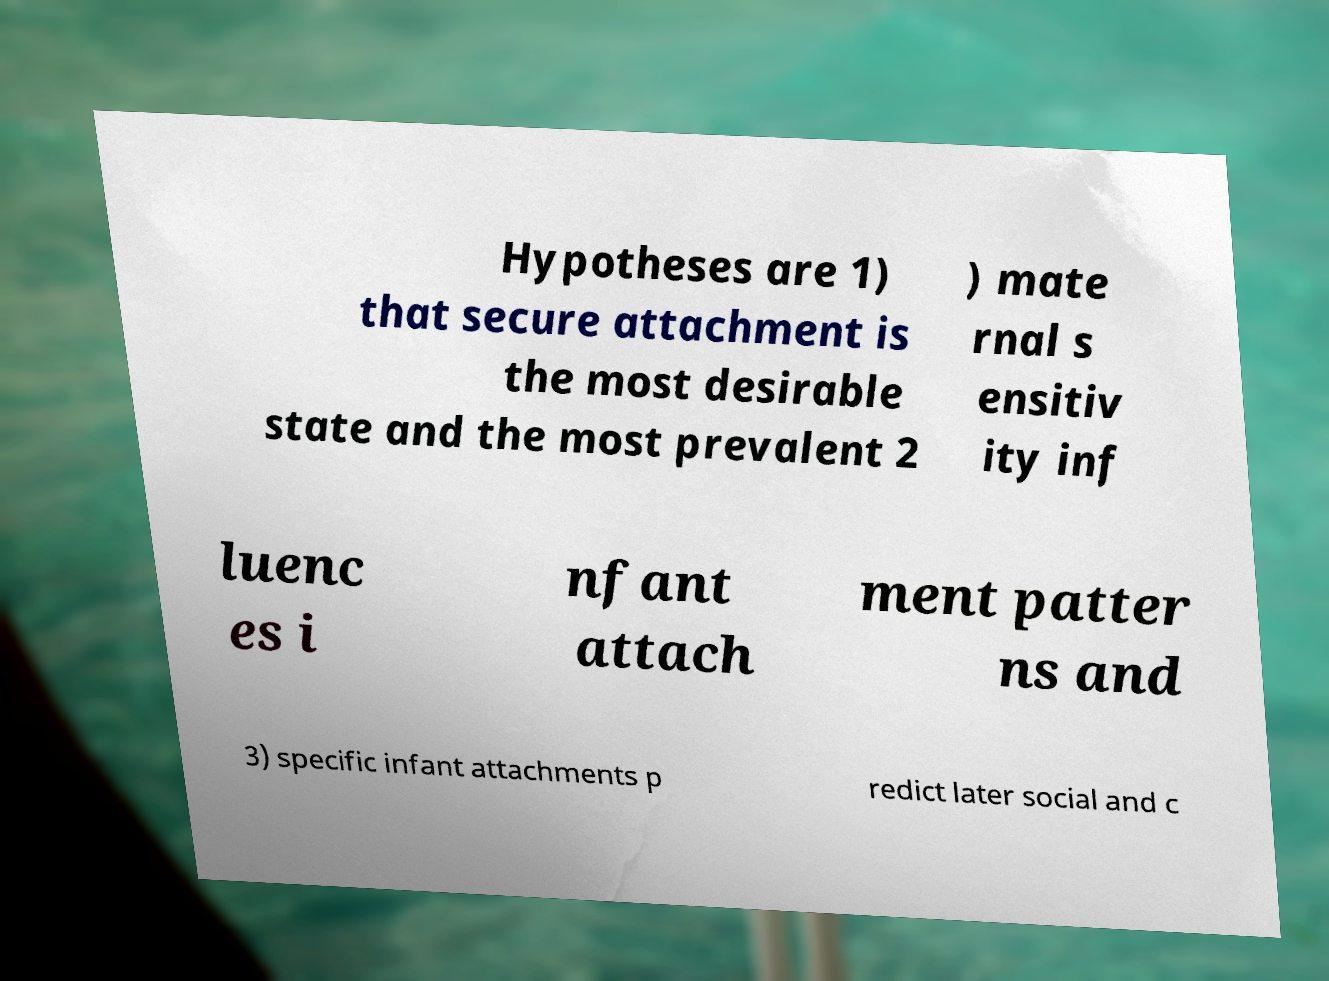For documentation purposes, I need the text within this image transcribed. Could you provide that? Hypotheses are 1) that secure attachment is the most desirable state and the most prevalent 2 ) mate rnal s ensitiv ity inf luenc es i nfant attach ment patter ns and 3) specific infant attachments p redict later social and c 